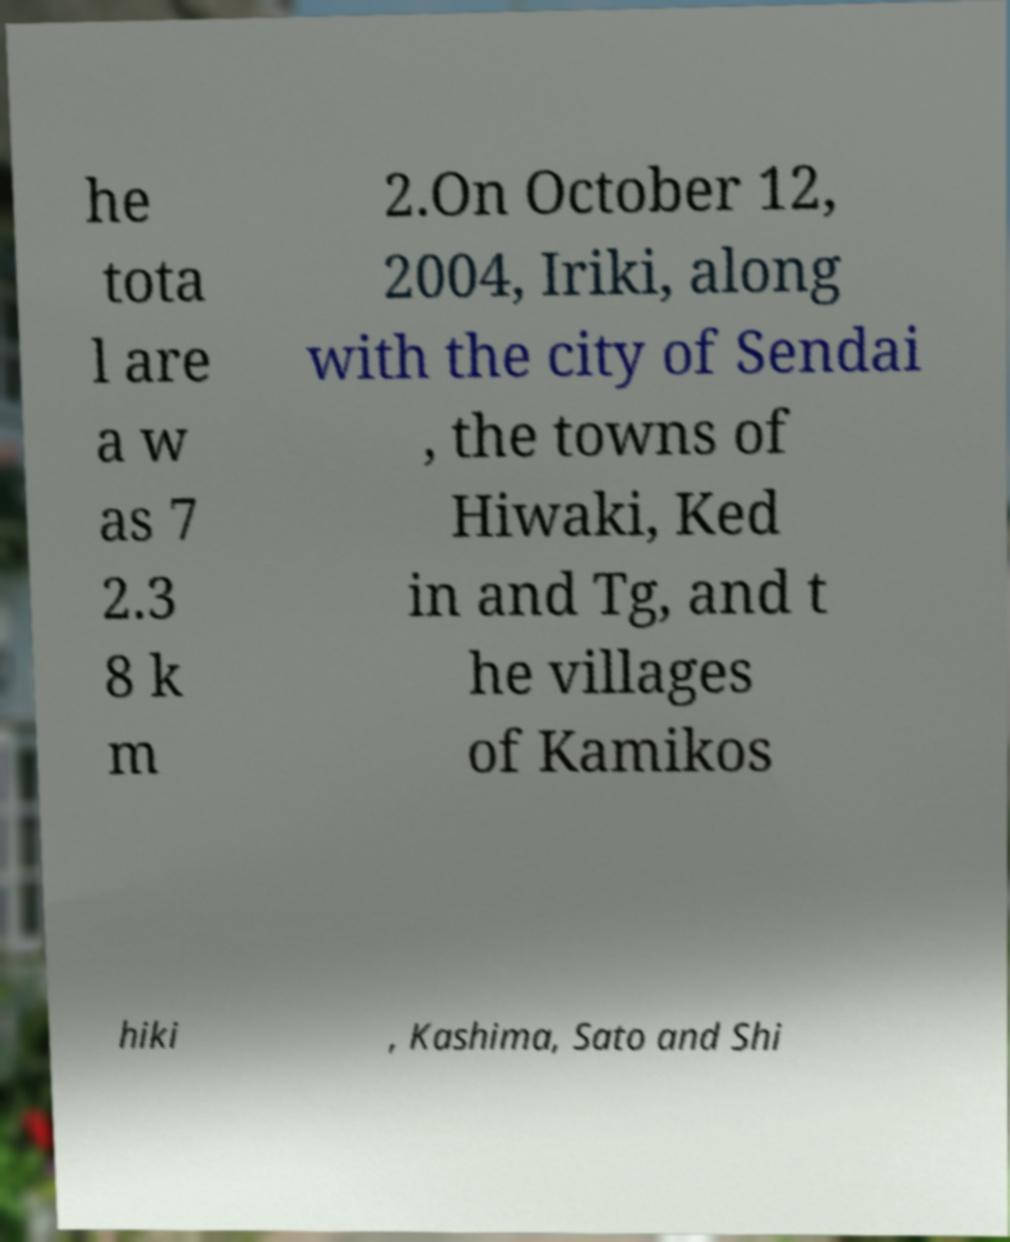What messages or text are displayed in this image? I need them in a readable, typed format. he tota l are a w as 7 2.3 8 k m 2.On October 12, 2004, Iriki, along with the city of Sendai , the towns of Hiwaki, Ked in and Tg, and t he villages of Kamikos hiki , Kashima, Sato and Shi 